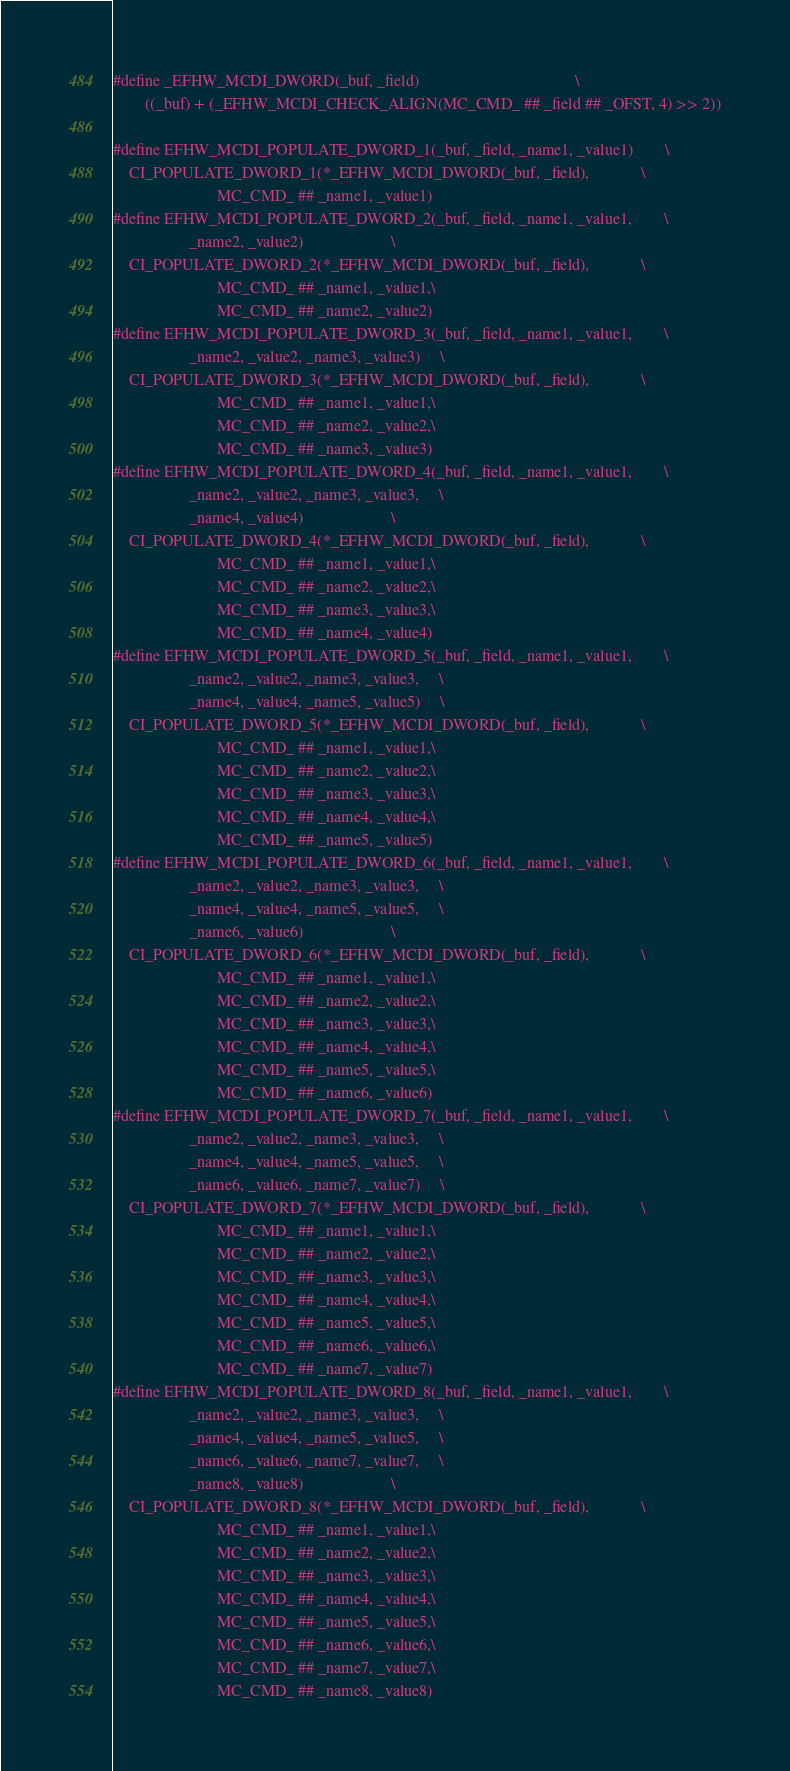Convert code to text. <code><loc_0><loc_0><loc_500><loc_500><_C_>#define _EFHW_MCDI_DWORD(_buf, _field)                                       \
        ((_buf) + (_EFHW_MCDI_CHECK_ALIGN(MC_CMD_ ## _field ## _OFST, 4) >> 2))

#define EFHW_MCDI_POPULATE_DWORD_1(_buf, _field, _name1, _value1)        \
	CI_POPULATE_DWORD_1(*_EFHW_MCDI_DWORD(_buf, _field),             \
					      MC_CMD_ ## _name1, _value1)
#define EFHW_MCDI_POPULATE_DWORD_2(_buf, _field, _name1, _value1,        \
				   _name2, _value2)                      \
	CI_POPULATE_DWORD_2(*_EFHW_MCDI_DWORD(_buf, _field),             \
					      MC_CMD_ ## _name1, _value1,\
					      MC_CMD_ ## _name2, _value2)
#define EFHW_MCDI_POPULATE_DWORD_3(_buf, _field, _name1, _value1,        \
				   _name2, _value2, _name3, _value3)     \
	CI_POPULATE_DWORD_3(*_EFHW_MCDI_DWORD(_buf, _field),             \
					      MC_CMD_ ## _name1, _value1,\
					      MC_CMD_ ## _name2, _value2,\
					      MC_CMD_ ## _name3, _value3)
#define EFHW_MCDI_POPULATE_DWORD_4(_buf, _field, _name1, _value1,        \
				   _name2, _value2, _name3, _value3,     \
				   _name4, _value4)                      \
	CI_POPULATE_DWORD_4(*_EFHW_MCDI_DWORD(_buf, _field),             \
					      MC_CMD_ ## _name1, _value1,\
					      MC_CMD_ ## _name2, _value2,\
					      MC_CMD_ ## _name3, _value3,\
					      MC_CMD_ ## _name4, _value4)
#define EFHW_MCDI_POPULATE_DWORD_5(_buf, _field, _name1, _value1,        \
				   _name2, _value2, _name3, _value3,     \
				   _name4, _value4, _name5, _value5)     \
	CI_POPULATE_DWORD_5(*_EFHW_MCDI_DWORD(_buf, _field),             \
					      MC_CMD_ ## _name1, _value1,\
					      MC_CMD_ ## _name2, _value2,\
					      MC_CMD_ ## _name3, _value3,\
					      MC_CMD_ ## _name4, _value4,\
					      MC_CMD_ ## _name5, _value5)
#define EFHW_MCDI_POPULATE_DWORD_6(_buf, _field, _name1, _value1,        \
				   _name2, _value2, _name3, _value3,     \
				   _name4, _value4, _name5, _value5,     \
				   _name6, _value6)                      \
	CI_POPULATE_DWORD_6(*_EFHW_MCDI_DWORD(_buf, _field),             \
					      MC_CMD_ ## _name1, _value1,\
					      MC_CMD_ ## _name2, _value2,\
					      MC_CMD_ ## _name3, _value3,\
					      MC_CMD_ ## _name4, _value4,\
					      MC_CMD_ ## _name5, _value5,\
					      MC_CMD_ ## _name6, _value6)
#define EFHW_MCDI_POPULATE_DWORD_7(_buf, _field, _name1, _value1,        \
				   _name2, _value2, _name3, _value3,     \
				   _name4, _value4, _name5, _value5,     \
				   _name6, _value6, _name7, _value7)     \
	CI_POPULATE_DWORD_7(*_EFHW_MCDI_DWORD(_buf, _field),             \
					      MC_CMD_ ## _name1, _value1,\
					      MC_CMD_ ## _name2, _value2,\
					      MC_CMD_ ## _name3, _value3,\
					      MC_CMD_ ## _name4, _value4,\
					      MC_CMD_ ## _name5, _value5,\
					      MC_CMD_ ## _name6, _value6,\
					      MC_CMD_ ## _name7, _value7)
#define EFHW_MCDI_POPULATE_DWORD_8(_buf, _field, _name1, _value1,        \
				   _name2, _value2, _name3, _value3,     \
				   _name4, _value4, _name5, _value5,     \
				   _name6, _value6, _name7, _value7,     \
				   _name8, _value8)                      \
	CI_POPULATE_DWORD_8(*_EFHW_MCDI_DWORD(_buf, _field),             \
					      MC_CMD_ ## _name1, _value1,\
					      MC_CMD_ ## _name2, _value2,\
					      MC_CMD_ ## _name3, _value3,\
					      MC_CMD_ ## _name4, _value4,\
					      MC_CMD_ ## _name5, _value5,\
					      MC_CMD_ ## _name6, _value6,\
					      MC_CMD_ ## _name7, _value7,\
					      MC_CMD_ ## _name8, _value8)</code> 